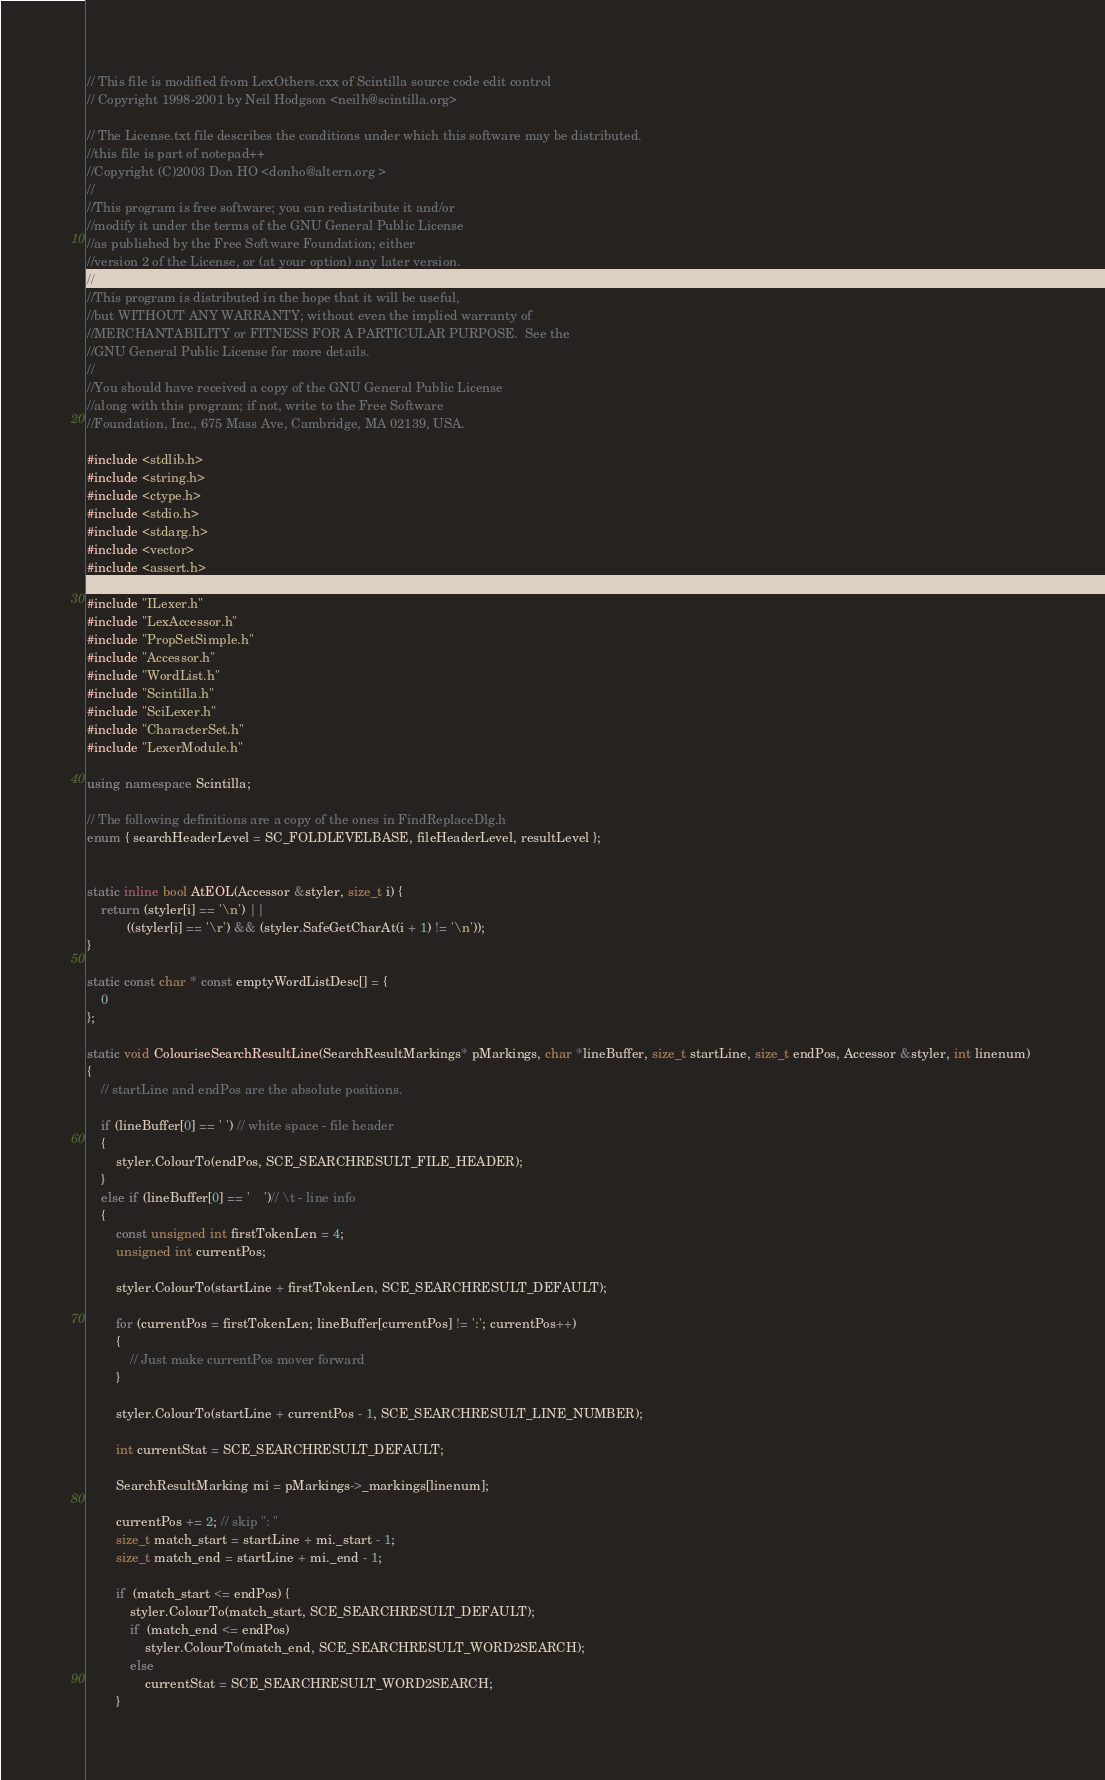Convert code to text. <code><loc_0><loc_0><loc_500><loc_500><_C++_>// This file is modified from LexOthers.cxx of Scintilla source code edit control
// Copyright 1998-2001 by Neil Hodgson <neilh@scintilla.org>

// The License.txt file describes the conditions under which this software may be distributed.
//this file is part of notepad++
//Copyright (C)2003 Don HO <donho@altern.org >
//
//This program is free software; you can redistribute it and/or
//modify it under the terms of the GNU General Public License
//as published by the Free Software Foundation; either
//version 2 of the License, or (at your option) any later version.
//
//This program is distributed in the hope that it will be useful,
//but WITHOUT ANY WARRANTY; without even the implied warranty of
//MERCHANTABILITY or FITNESS FOR A PARTICULAR PURPOSE.  See the
//GNU General Public License for more details.
//
//You should have received a copy of the GNU General Public License
//along with this program; if not, write to the Free Software
//Foundation, Inc., 675 Mass Ave, Cambridge, MA 02139, USA.

#include <stdlib.h>
#include <string.h>
#include <ctype.h>
#include <stdio.h>
#include <stdarg.h>
#include <vector>
#include <assert.h>

#include "ILexer.h"
#include "LexAccessor.h"
#include "PropSetSimple.h"
#include "Accessor.h"
#include "WordList.h"
#include "Scintilla.h"
#include "SciLexer.h"
#include "CharacterSet.h"
#include "LexerModule.h"

using namespace Scintilla;

// The following definitions are a copy of the ones in FindReplaceDlg.h
enum { searchHeaderLevel = SC_FOLDLEVELBASE, fileHeaderLevel, resultLevel };


static inline bool AtEOL(Accessor &styler, size_t i) {
	return (styler[i] == '\n') ||
	       ((styler[i] == '\r') && (styler.SafeGetCharAt(i + 1) != '\n'));
}

static const char * const emptyWordListDesc[] = {
	0
};

static void ColouriseSearchResultLine(SearchResultMarkings* pMarkings, char *lineBuffer, size_t startLine, size_t endPos, Accessor &styler, int linenum) 
{
	// startLine and endPos are the absolute positions.

	if (lineBuffer[0] == ' ') // white space - file header
	{
		styler.ColourTo(endPos, SCE_SEARCHRESULT_FILE_HEADER);
	}
	else if (lineBuffer[0] == '	')// \t - line info
	{
		const unsigned int firstTokenLen = 4;
		unsigned int currentPos;

		styler.ColourTo(startLine + firstTokenLen, SCE_SEARCHRESULT_DEFAULT);
		
		for (currentPos = firstTokenLen; lineBuffer[currentPos] != ':'; currentPos++)
		{
			// Just make currentPos mover forward
		}

		styler.ColourTo(startLine + currentPos - 1, SCE_SEARCHRESULT_LINE_NUMBER);
		
		int currentStat = SCE_SEARCHRESULT_DEFAULT;

		SearchResultMarking mi = pMarkings->_markings[linenum];

		currentPos += 2; // skip ": "
		size_t match_start = startLine + mi._start - 1;
		size_t match_end = startLine + mi._end - 1;

		if  (match_start <= endPos) {
			styler.ColourTo(match_start, SCE_SEARCHRESULT_DEFAULT);
			if  (match_end <= endPos) 
				styler.ColourTo(match_end, SCE_SEARCHRESULT_WORD2SEARCH);
			else 
				currentStat = SCE_SEARCHRESULT_WORD2SEARCH;
		}</code> 